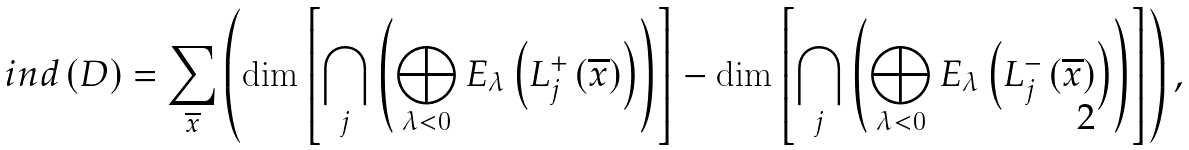Convert formula to latex. <formula><loc_0><loc_0><loc_500><loc_500>i n d \left ( D \right ) = \sum _ { \overline { x } } \left ( \dim \left [ \bigcap _ { j } \left ( \bigoplus _ { \lambda < 0 } E _ { \lambda } \left ( L _ { j } ^ { + } \left ( \overline { x } \right ) \right ) \right ) \right ] - \dim \left [ \bigcap _ { j } \left ( \bigoplus _ { \lambda < 0 } E _ { \lambda } \left ( L _ { j } ^ { - } \left ( \overline { x } \right ) \right ) \right ) \right ] \right ) ,</formula> 